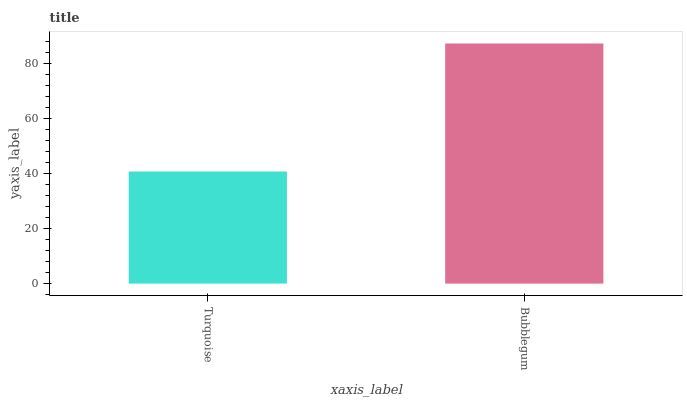Is Bubblegum the minimum?
Answer yes or no. No. Is Bubblegum greater than Turquoise?
Answer yes or no. Yes. Is Turquoise less than Bubblegum?
Answer yes or no. Yes. Is Turquoise greater than Bubblegum?
Answer yes or no. No. Is Bubblegum less than Turquoise?
Answer yes or no. No. Is Bubblegum the high median?
Answer yes or no. Yes. Is Turquoise the low median?
Answer yes or no. Yes. Is Turquoise the high median?
Answer yes or no. No. Is Bubblegum the low median?
Answer yes or no. No. 